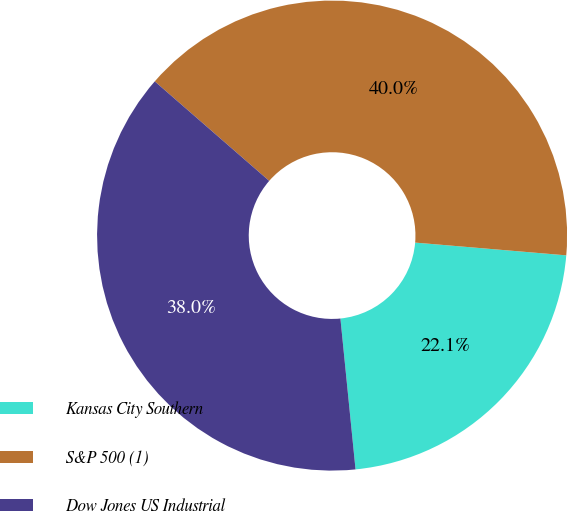<chart> <loc_0><loc_0><loc_500><loc_500><pie_chart><fcel>Kansas City Southern<fcel>S&P 500 (1)<fcel>Dow Jones US Industrial<nl><fcel>22.07%<fcel>39.95%<fcel>37.98%<nl></chart> 